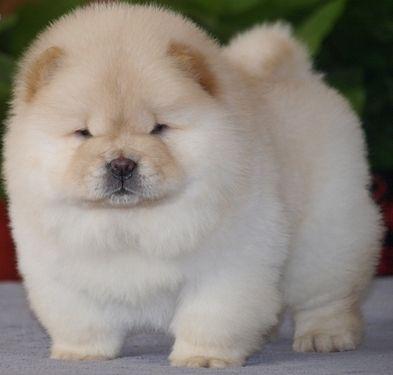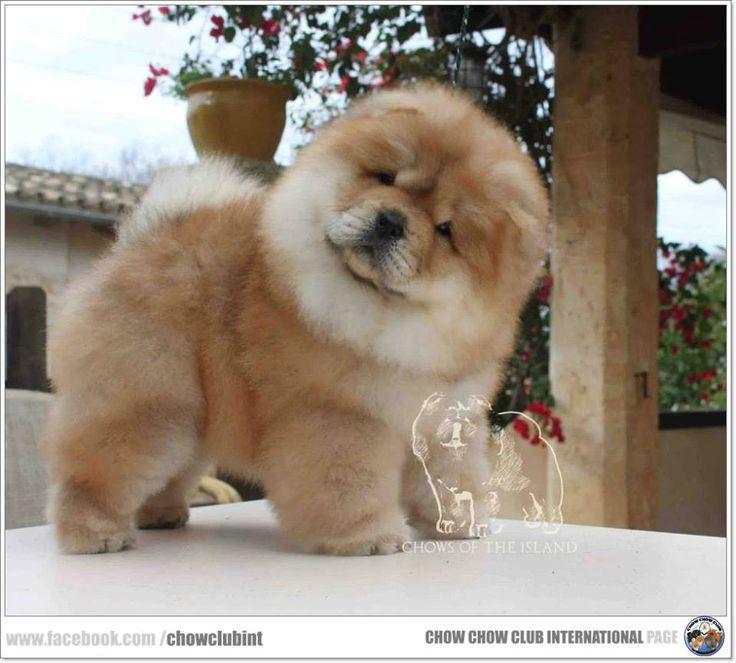The first image is the image on the left, the second image is the image on the right. Given the left and right images, does the statement "The right image shows a chow eyeing the camera, with its head turned at a distinct angle." hold true? Answer yes or no. Yes. 